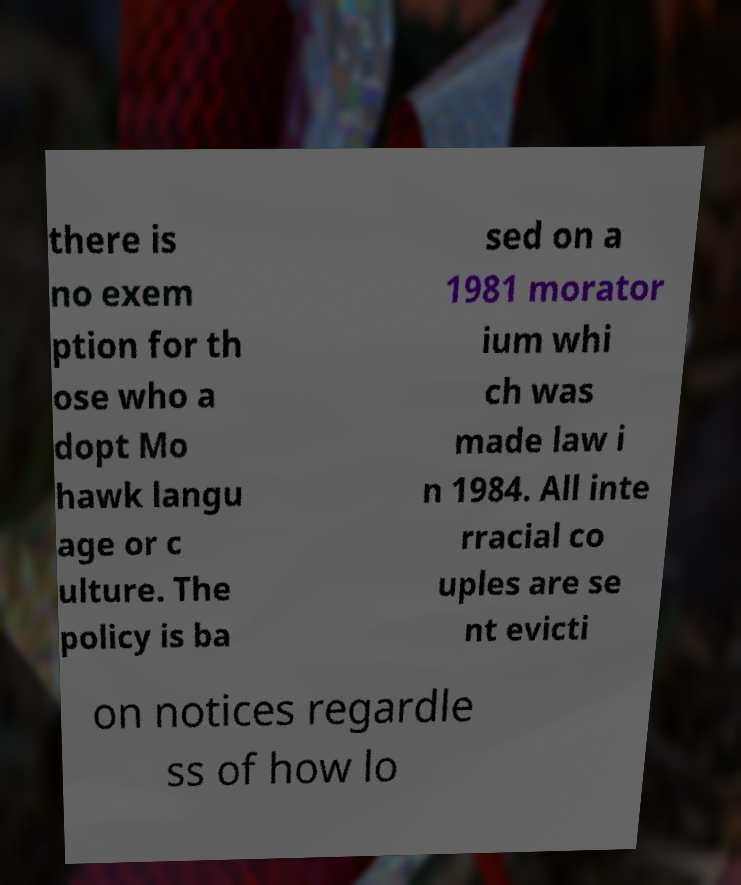What messages or text are displayed in this image? I need them in a readable, typed format. there is no exem ption for th ose who a dopt Mo hawk langu age or c ulture. The policy is ba sed on a 1981 morator ium whi ch was made law i n 1984. All inte rracial co uples are se nt evicti on notices regardle ss of how lo 